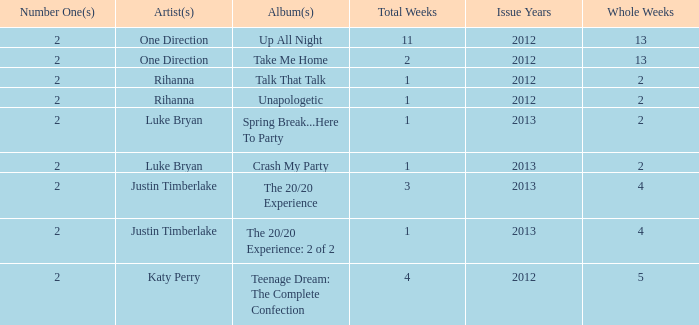What is the title of every song, and how many weeks was each song at #1 for One Direction? Up All Night — 11, Take Me Home — 2. 